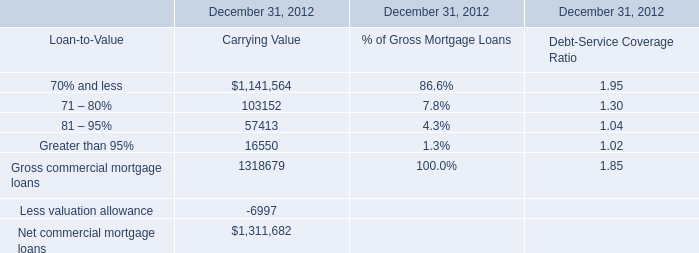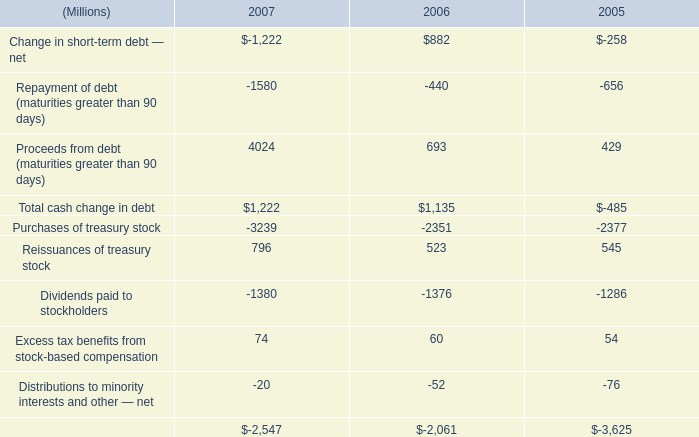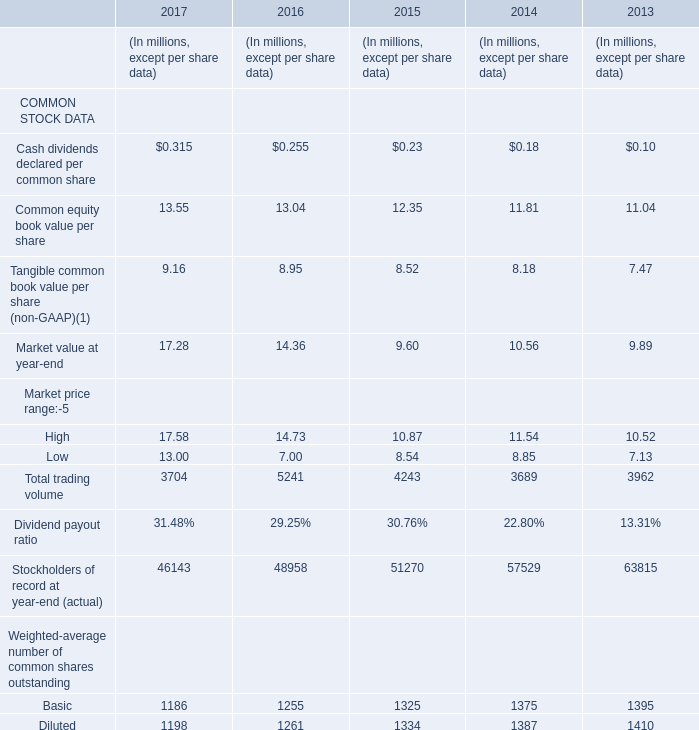If Common equity book value per share develops with the same growth rate in 2016, what will it reach in 2017? 
Computations: (13.04 * (1 + ((13.04 - 12.35) / 12.35)))
Answer: 13.76855. 